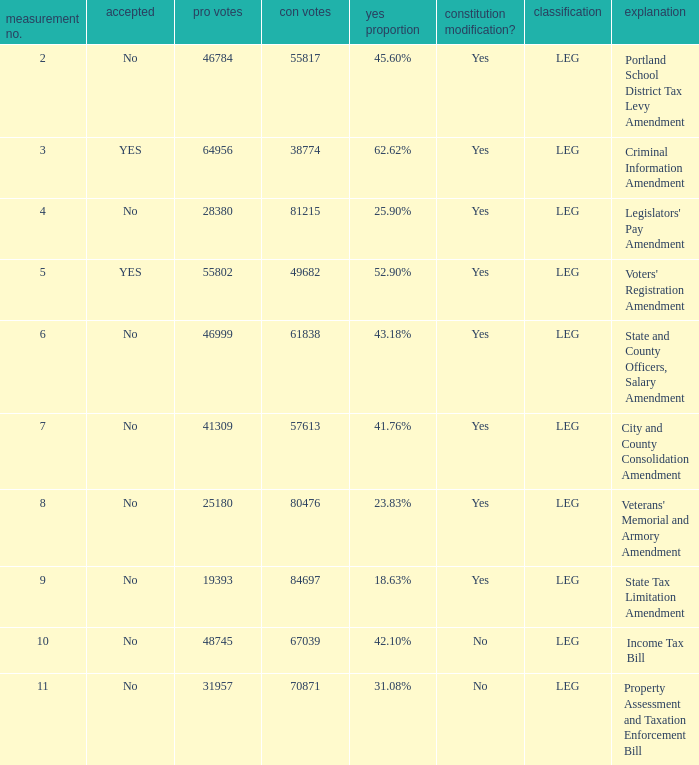How many yes votes made up 43.18% yes? 46999.0. 